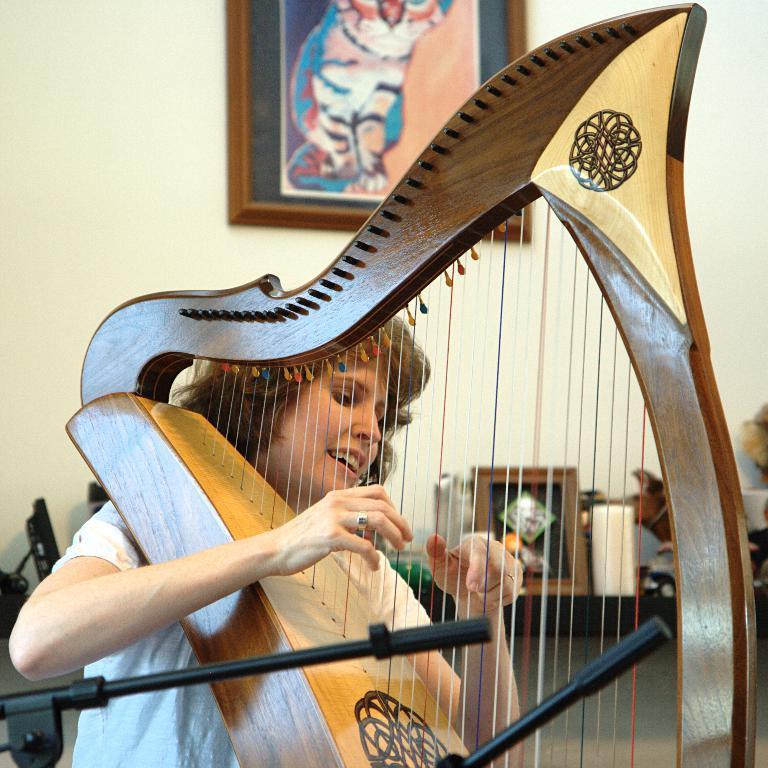Please provide a concise description of this image. In this picture, we see a woman in the white T-shirt is playing the musical instrument and she is smiling. Beside her, we see the microphones. Behind her, we see a photo frame and some other objects. In the background, we see a white wall on which a photo frame is placed. This picture might be clicked in the room. 